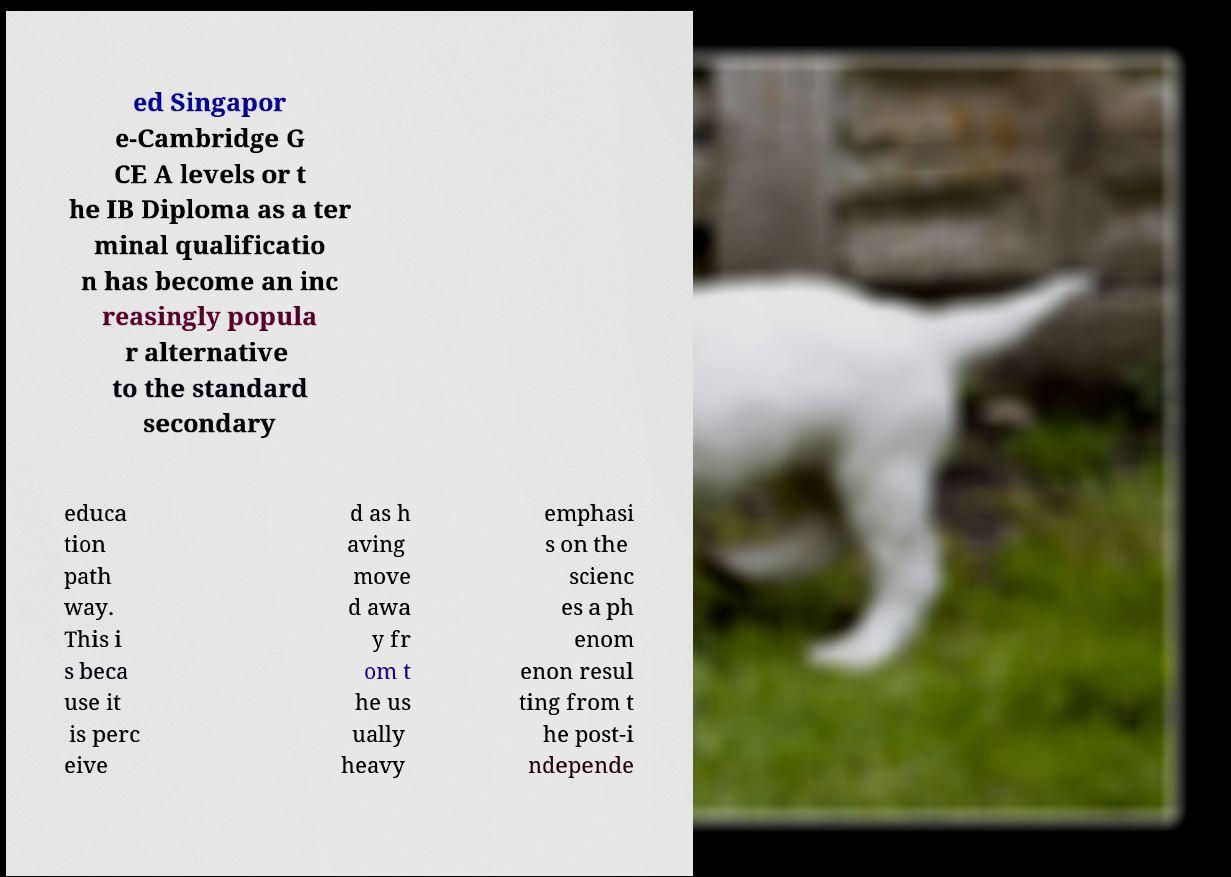Please read and relay the text visible in this image. What does it say? ed Singapor e-Cambridge G CE A levels or t he IB Diploma as a ter minal qualificatio n has become an inc reasingly popula r alternative to the standard secondary educa tion path way. This i s beca use it is perc eive d as h aving move d awa y fr om t he us ually heavy emphasi s on the scienc es a ph enom enon resul ting from t he post-i ndepende 